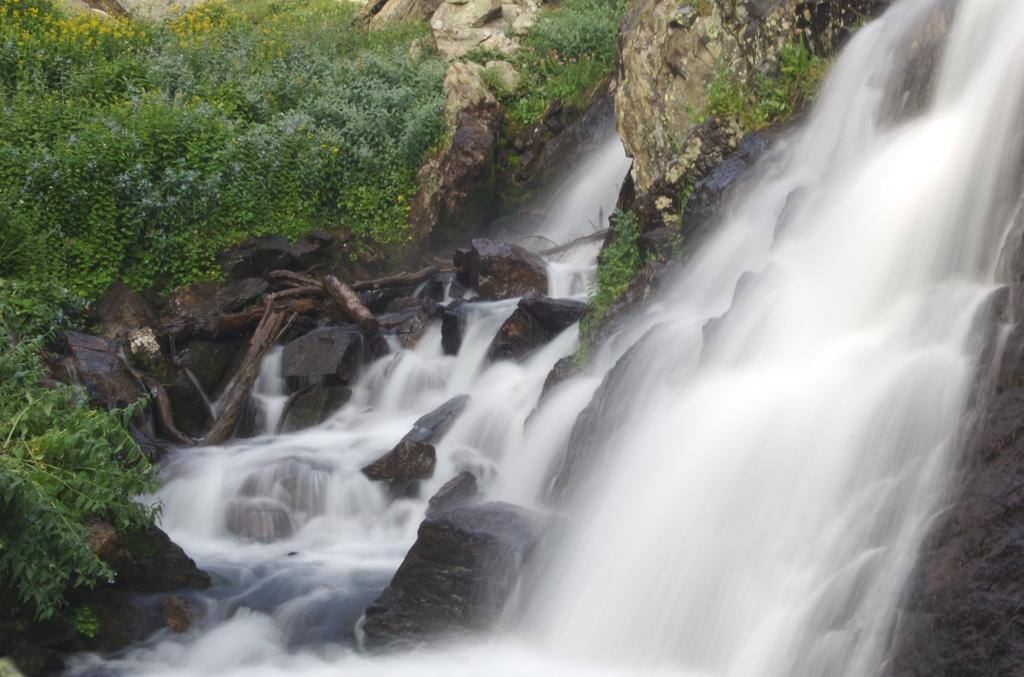Could you give a brief overview of what you see in this image? In this image there are rocky mountains. There are trees and plants on the mountains. To the right there is a waterfall on the rocks. There are tree trunks on the mountains. 